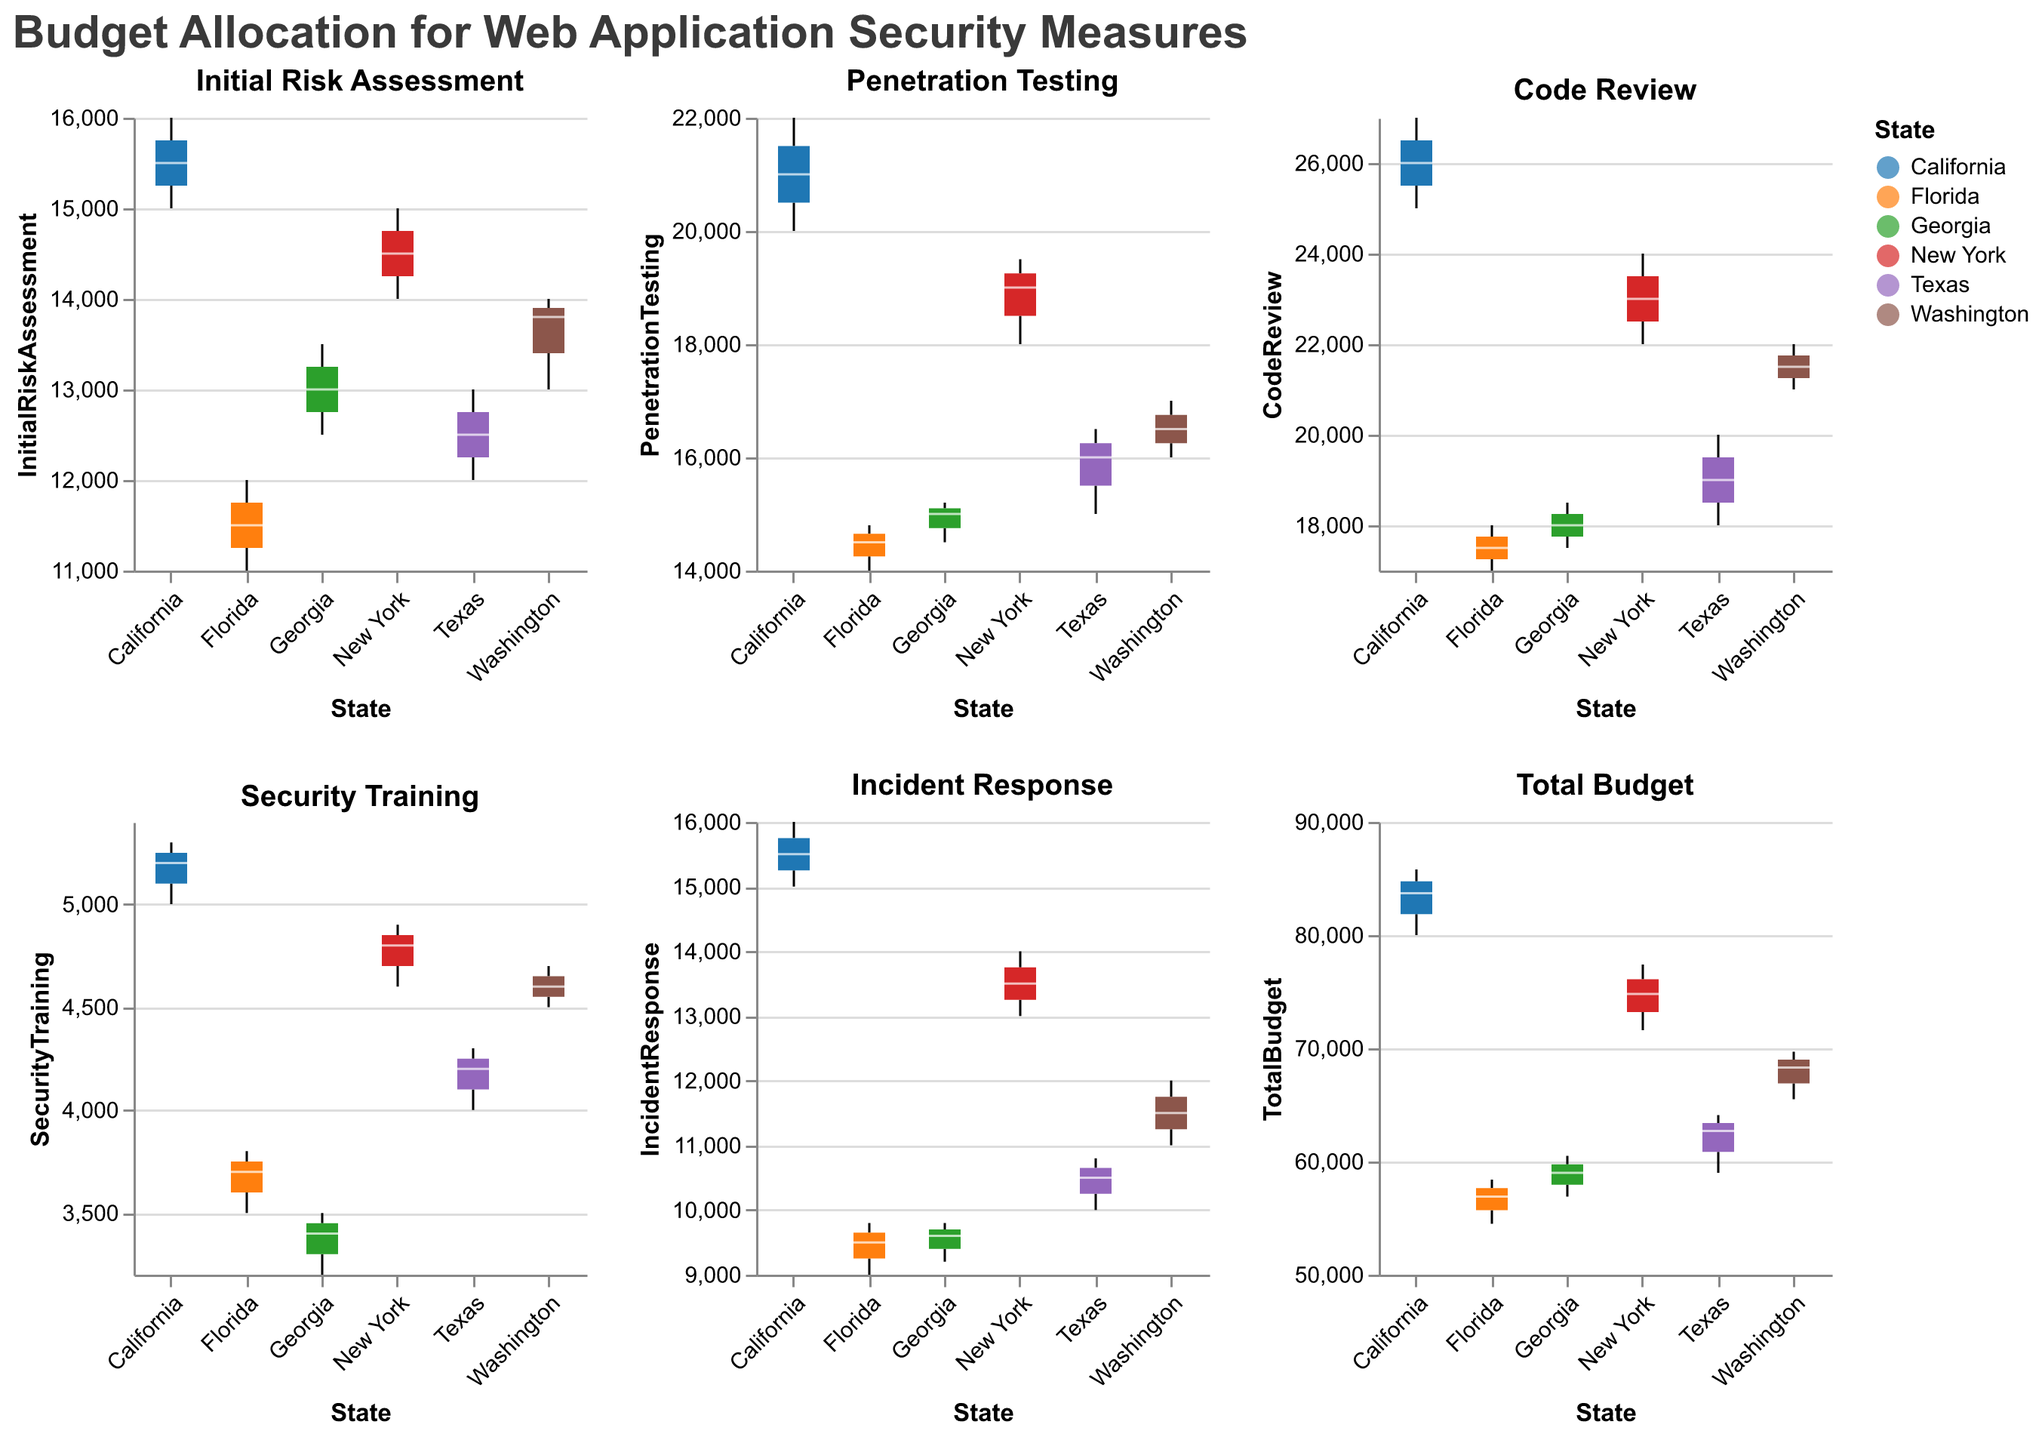What is the highest budget allocated for Initial Risk Assessment? To determine this, examine the "Initial Risk Assessment" subplot. Among all the states, identify the highest value at the top whisker of the box plots. The highest value is $16,000 for California in 2022.
Answer: $16,000 Which state has the lowest median budget for Code Review? Look at the median lines (usually colored white) in the "Code Review" subplot. The lowest median value among the states is identified as $17,000 for Florida.
Answer: Florida How does the median budget for Penetration Testing in Texas compare to that in Florida? In the "Penetration Testing" subplot, compare the median lines for Texas and Florida. Texas has a median budget of $16,000 for Penetration Testing, whereas Florida's median budget is $14,500. This means Texas has a higher median budget than Florida.
Answer: Texas has a higher median budget than Florida What is the range of the Security Training budget in Georgia over the three years? For Georgia in the "Security Training" subplot, identify the minimum and maximum values shown by the bottom and top whiskers. The Security Training budget in Georgia ranges from $3,200 to $3,500.
Answer: $3,200 to $3,500 Which expenditures have the greatest variability in California's budget allocations? Examine the size of the interquartile ranges and the lengths of the whiskers for California in each subplot. The "Code Review" and "Penetration Testing" show significant variability, but "Code Review" has the longest whiskers, indicating the greatest variability in spend.
Answer: Code Review By how much did the total budget increase on average per year in New York? In the "Total Budget" subplot, look at the New York box plots from 2021 to 2023. The budgets are: $71,600 (2021), $74,800 (2022), and $77,400 (2023). Compute the differences: ($74,800 - $71,600 = $3,200) and ($77,400 - $74,800 = $2,600). The average increase is ($3,200 + $2,600) / 2 = $2,900.
Answer: $2,900 What is the median budget for Incident Response in New York? In the "Incident Response" subplot, identify the median line for New York. The median value is seen as $13,500.
Answer: $13,500 Which state shows the highest increase in the total budget from 2021 to 2023? Look at the "Total Budget" subplot and compare the difference between the 2021 and 2023 values for each state. California shows the largest increase, going from $80,000 in 2021 to $85,800 in 2023. The increase is $85,800 - $80,000 = $5,800.
Answer: California 